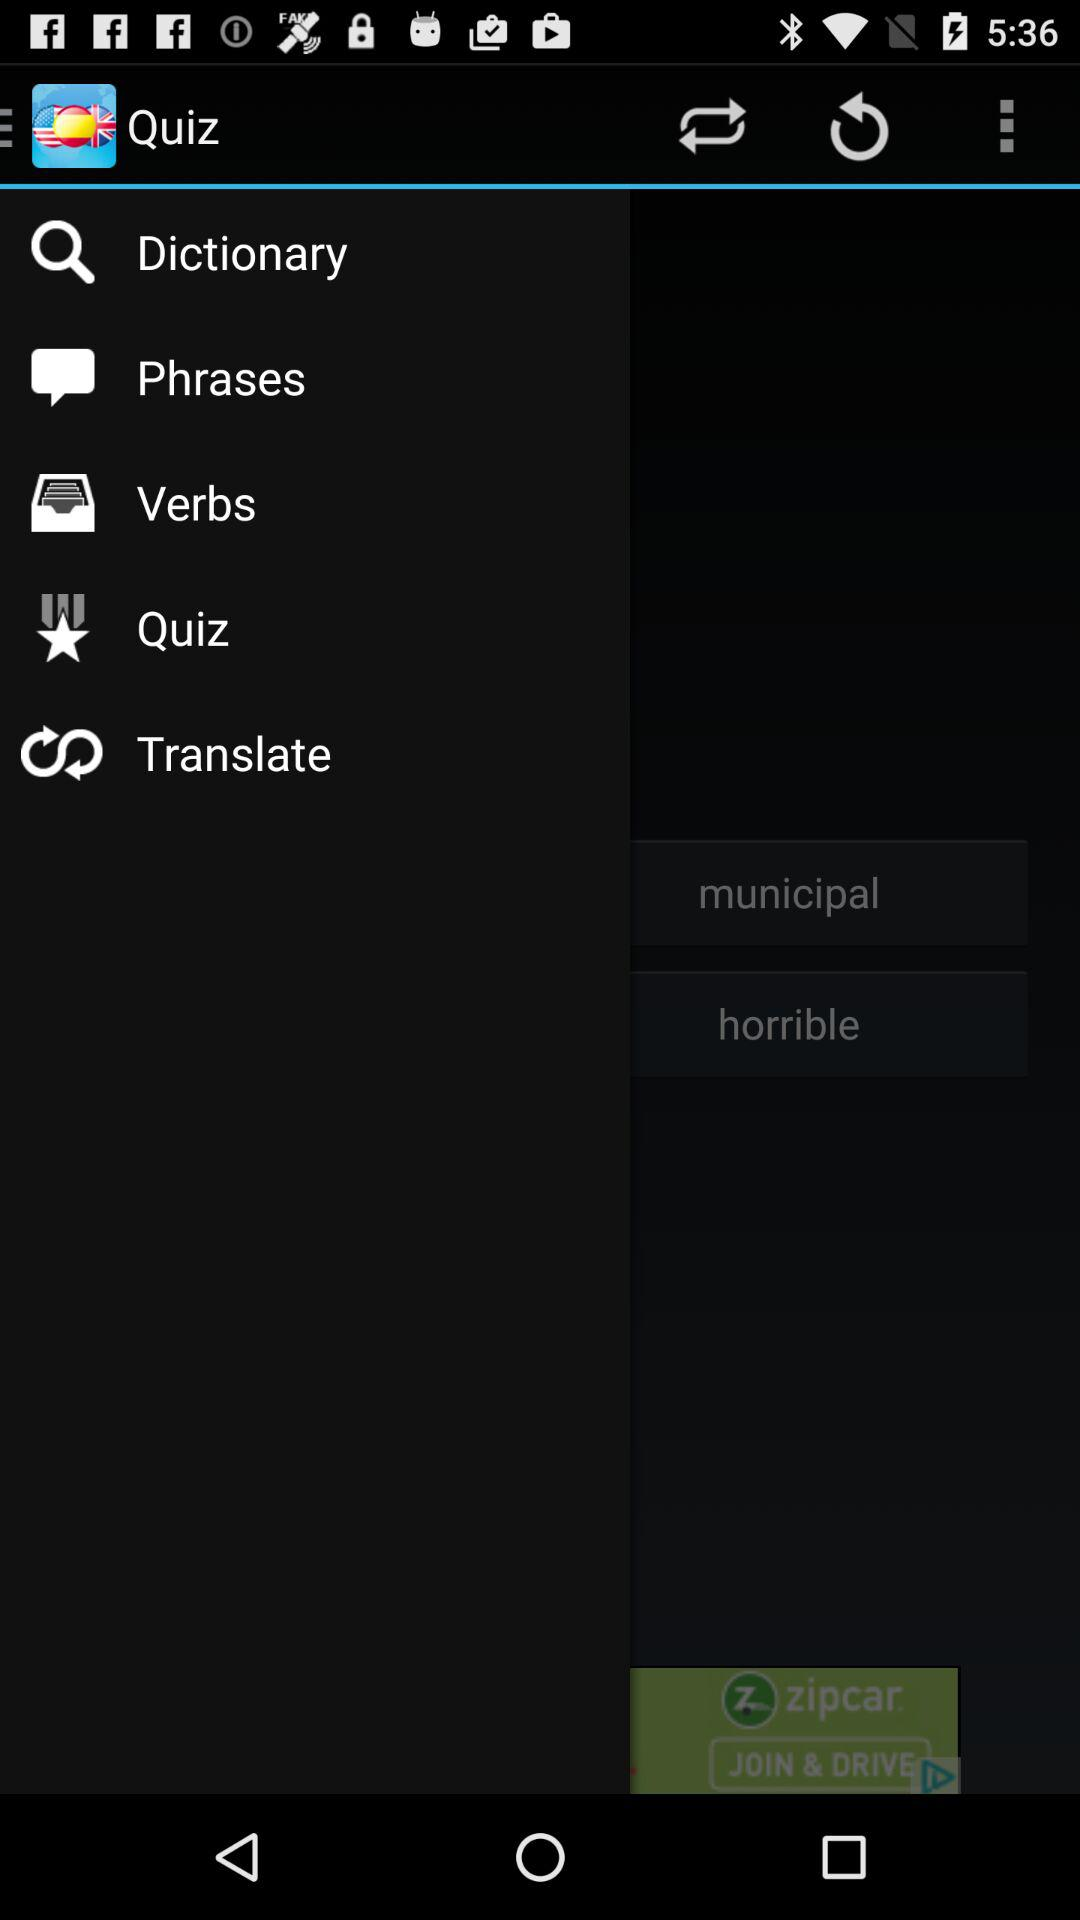Which languages are available to translate?
When the provided information is insufficient, respond with <no answer>. <no answer> 